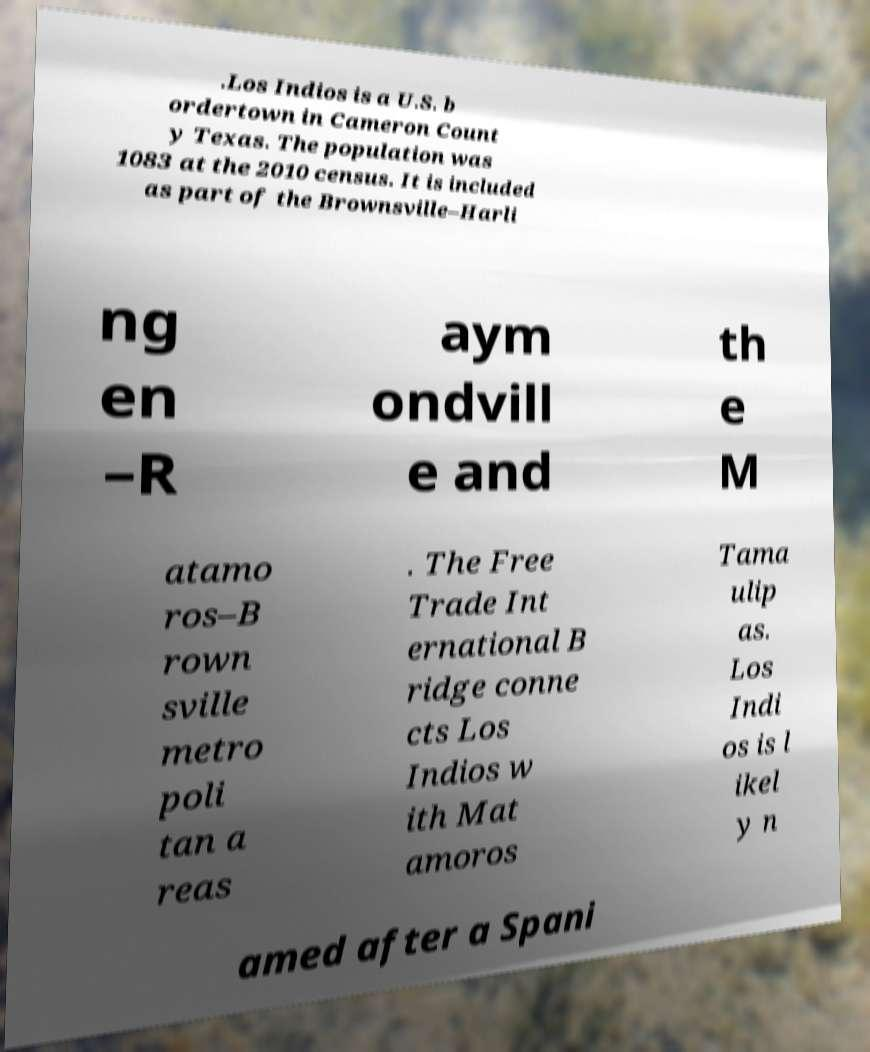Can you read and provide the text displayed in the image?This photo seems to have some interesting text. Can you extract and type it out for me? .Los Indios is a U.S. b ordertown in Cameron Count y Texas. The population was 1083 at the 2010 census. It is included as part of the Brownsville–Harli ng en –R aym ondvill e and th e M atamo ros–B rown sville metro poli tan a reas . The Free Trade Int ernational B ridge conne cts Los Indios w ith Mat amoros Tama ulip as. Los Indi os is l ikel y n amed after a Spani 